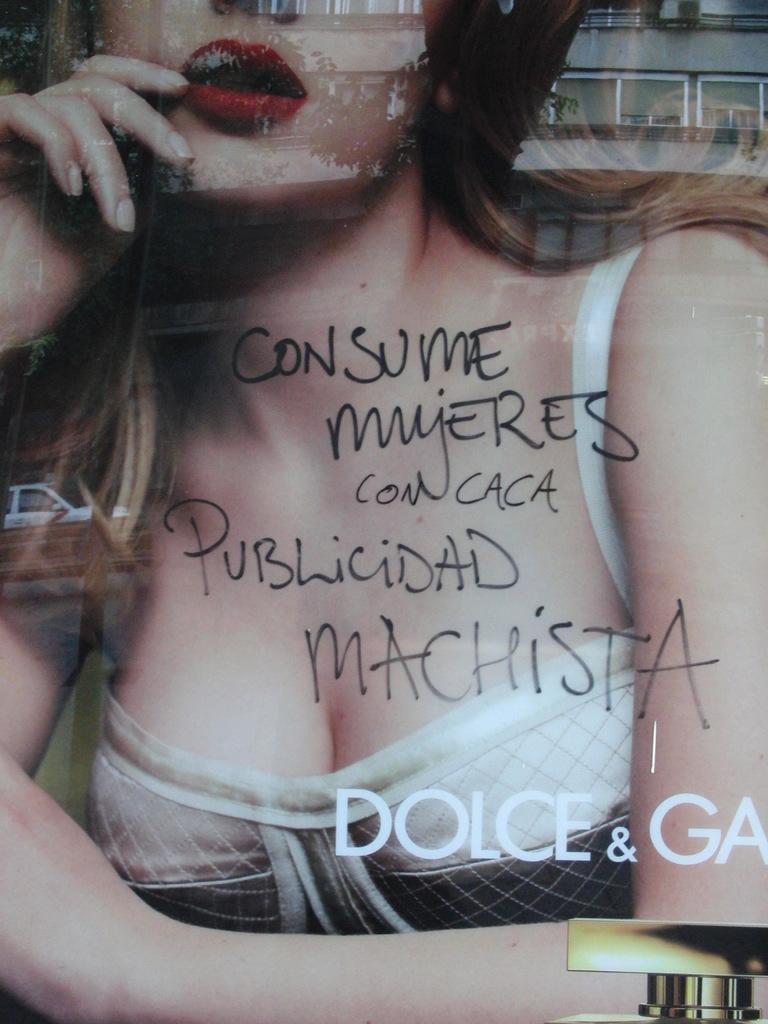In one or two sentences, can you explain what this image depicts? In the image there is a woman picture behind a glass with text above it. 